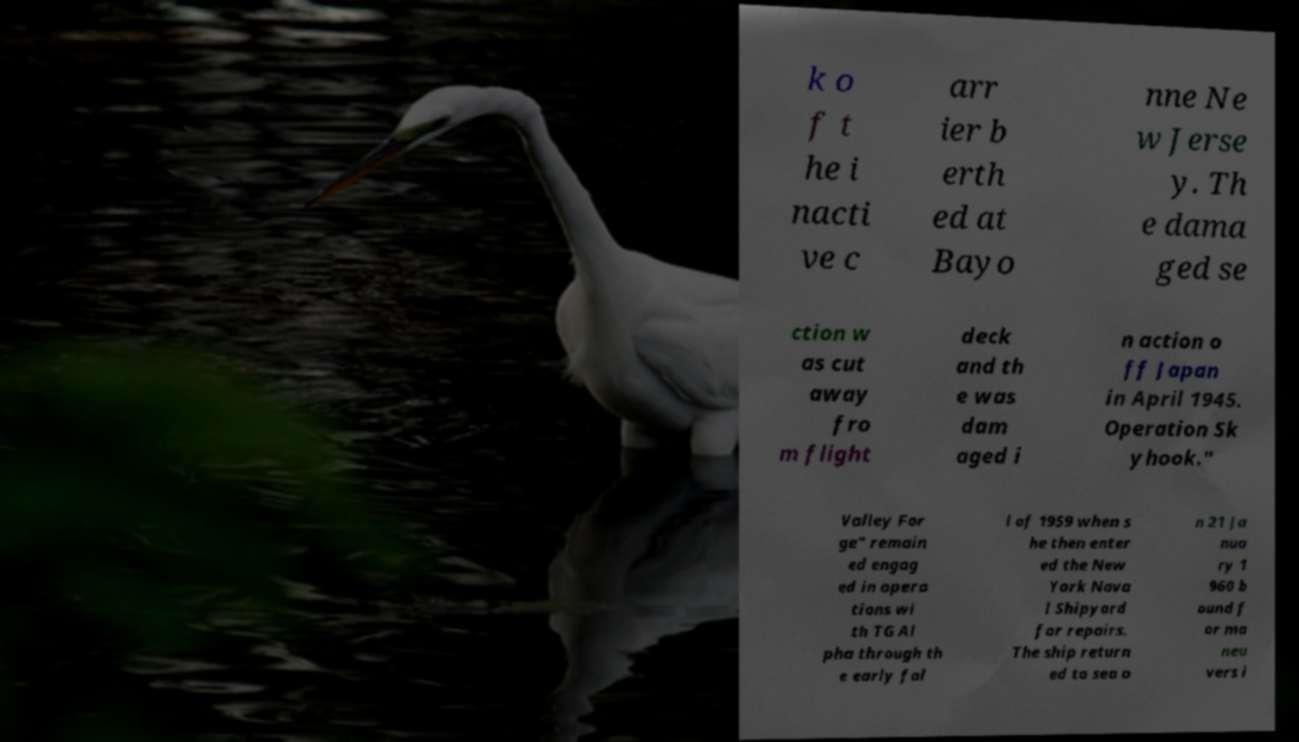Can you accurately transcribe the text from the provided image for me? k o f t he i nacti ve c arr ier b erth ed at Bayo nne Ne w Jerse y. Th e dama ged se ction w as cut away fro m flight deck and th e was dam aged i n action o ff Japan in April 1945. Operation Sk yhook." Valley For ge" remain ed engag ed in opera tions wi th TG Al pha through th e early fal l of 1959 when s he then enter ed the New York Nava l Shipyard for repairs. The ship return ed to sea o n 21 Ja nua ry 1 960 b ound f or ma neu vers i 